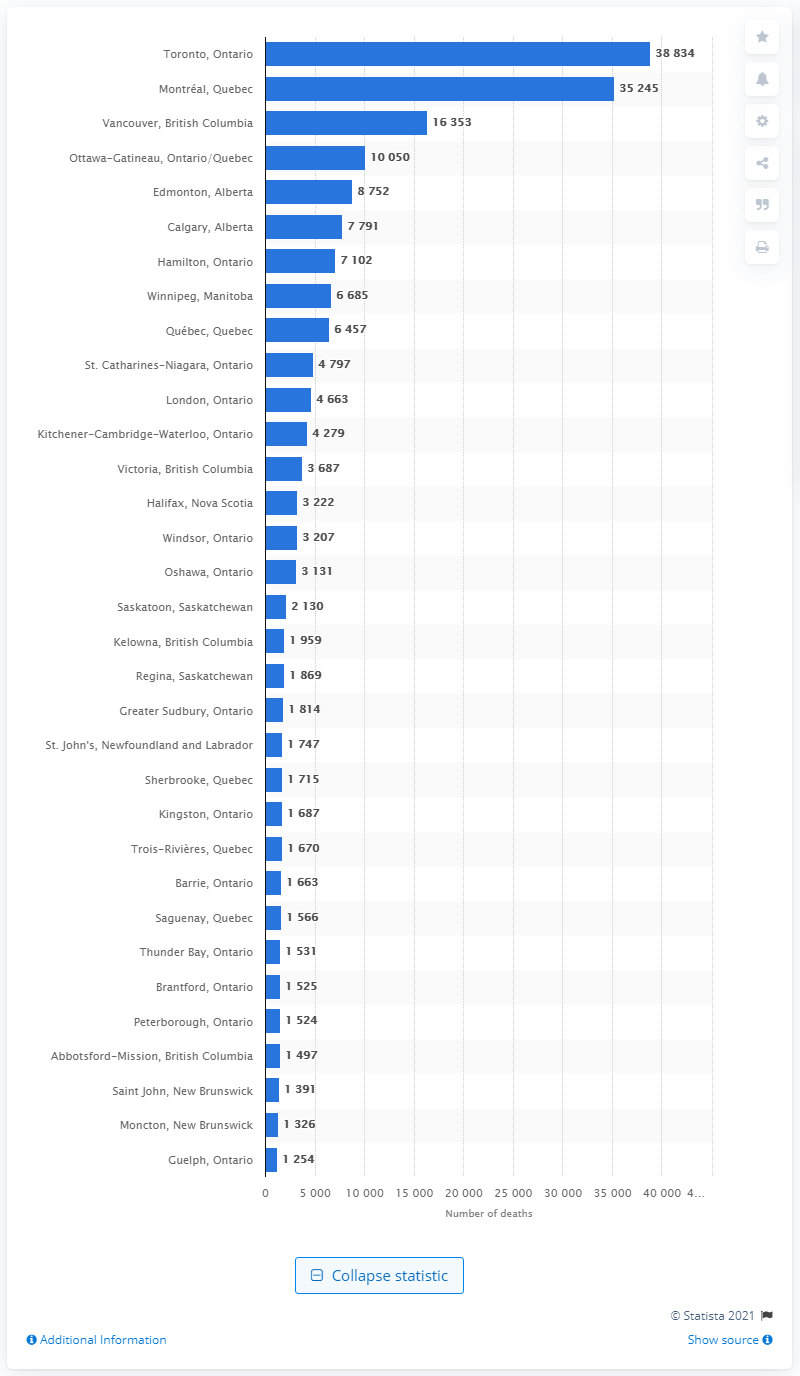Mention a couple of crucial points in this snapshot. During the period of July 1, 2019 to June 30, 2020 in Toronto, a total of 38,834 people died. 